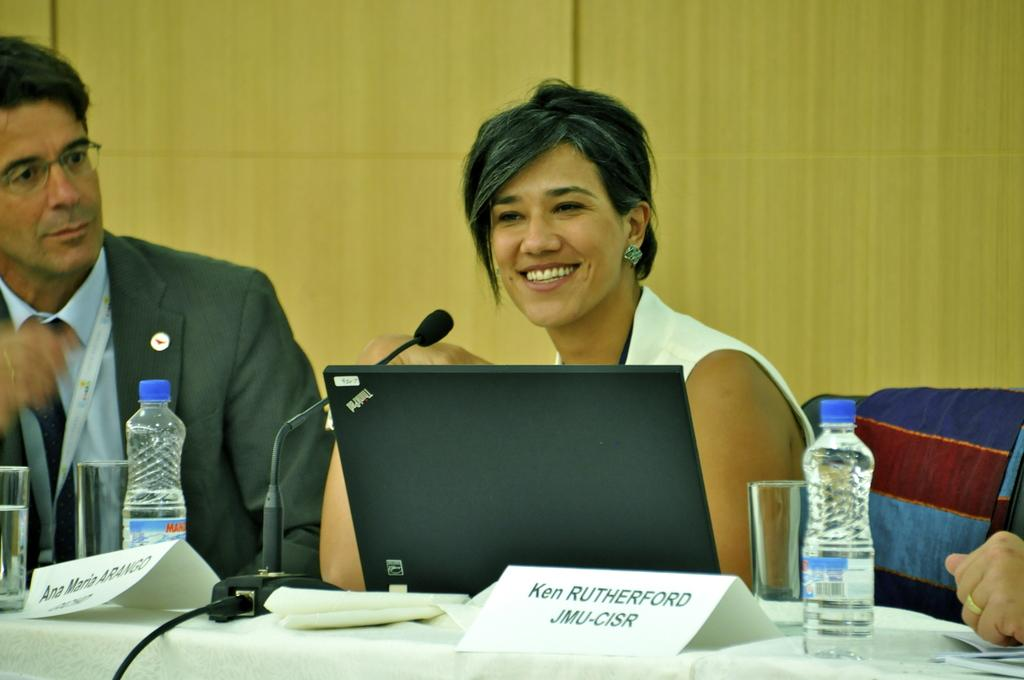How many people are in the image? There is a man and a woman in the image. What is the woman doing in the image? The woman is sitting on a chair. What is the woman's facial expression in the image? The woman is smiling. What is on the table in the image? There is a cloth, bottles, glasses, and papers on the table. What object related to sound is present in the image? There is a microphone (mike) in the image. What type of flesh can be seen on the woman's arm in the image? There is no flesh visible on the woman's arm in the image; she is fully clothed. Is there a door in the image? There is no door present in the image. 